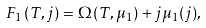<formula> <loc_0><loc_0><loc_500><loc_500>F _ { 1 } ( T , j ) = \Omega ( T , \mu _ { 1 } ) + j \mu _ { 1 } ( j ) ,</formula> 